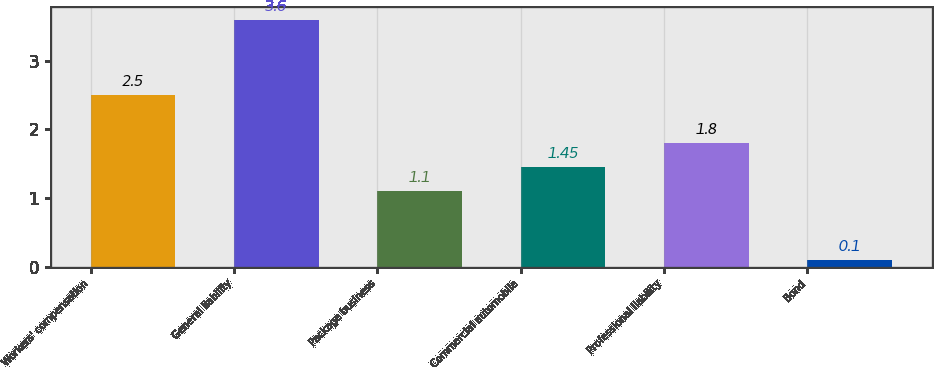Convert chart. <chart><loc_0><loc_0><loc_500><loc_500><bar_chart><fcel>Workers' compensation<fcel>General liability<fcel>Package business<fcel>Commercial automobile<fcel>Professional liability<fcel>Bond<nl><fcel>2.5<fcel>3.6<fcel>1.1<fcel>1.45<fcel>1.8<fcel>0.1<nl></chart> 